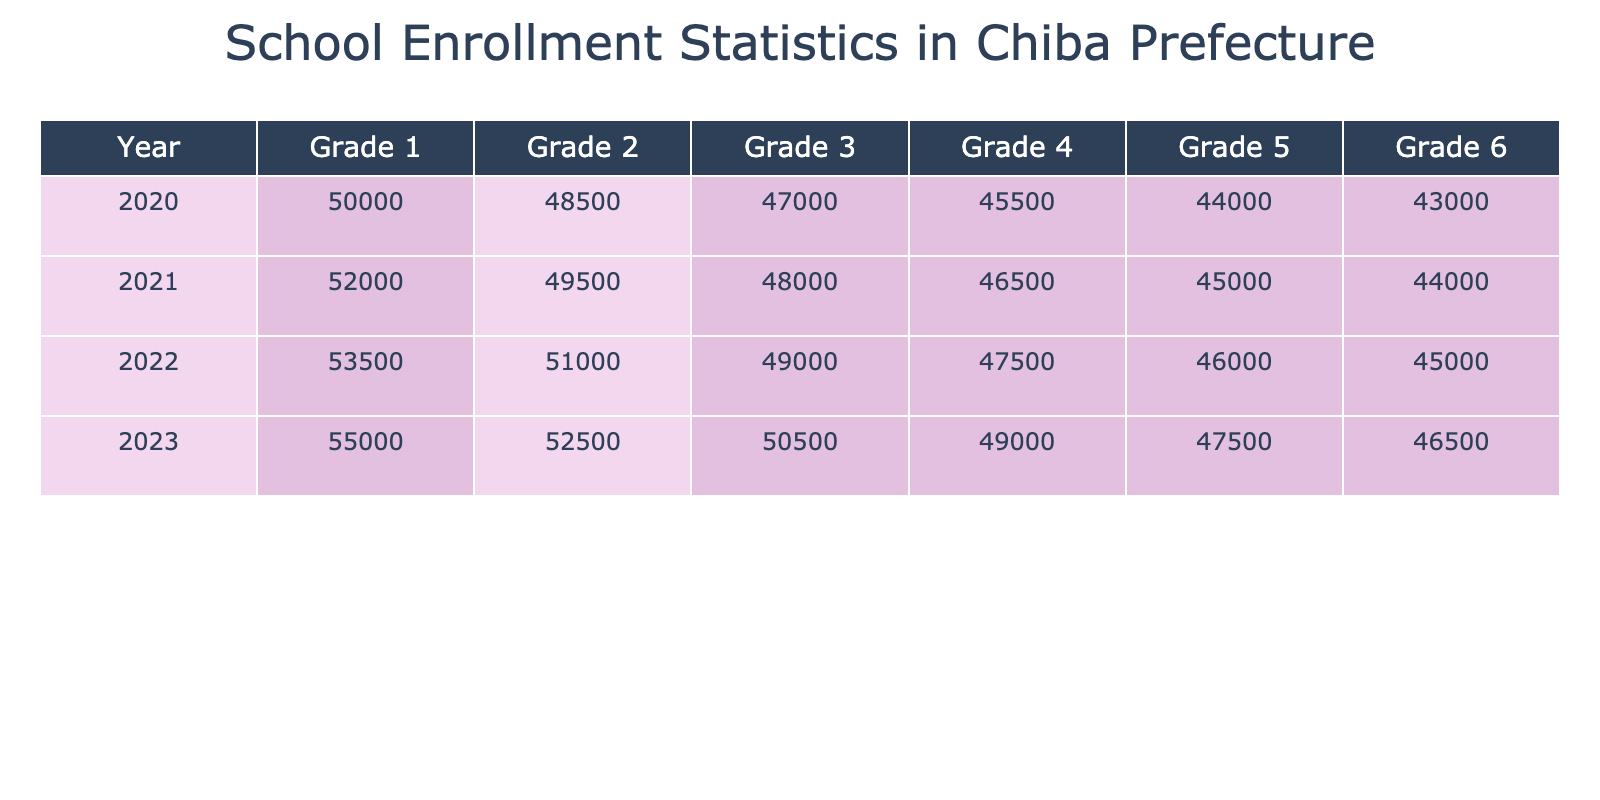What was the total enrollment for Grade 1 in 2022? The enrollment for Grade 1 in 2022 is listed in the table under that specific year and grade level. According to the data, the Total Enrollment for Grade 1 in 2022 is 53,500.
Answer: 53,500 How many students were enrolled in private schools in Grade 6 in 2021? The enrollment specifically for Grade 6 in the year 2021 needs to be looked up in the respective row. According to the data, the Private Schools Enrollment for Grade 6 in 2021 is 13,000.
Answer: 13,000 What is the difference in total enrollment between Grade 3 in 2020 and Grade 3 in 2023? To find this difference, we first look up the Total Enrollment for Grade 3 in both years from the table. For 2020, the total is 47,000 and for 2023, it is 50,500. The difference is calculated as 50,500 - 47,000 = 3,500.
Answer: 3,500 Is the total enrollment in Grade 5 in 2021 higher than in 2020? We need to find the Total Enrollment figures for Grade 5 in both years. In 2021, the Total Enrollment for Grade 5 is 45,000 and in 2020 it is 44,000. Comparing these two figures, 45,000 is indeed higher than 44,000. Therefore, the answer is Yes.
Answer: Yes What grade level had the highest total enrollment in 2023 and what was that enrollment? We need to check the Total Enrollment for all grade levels in 2023. In that year, Grade 1 has 55,000, Grade 2 has 52,500, Grade 3 has 50,500, Grade 4 has 49,000, Grade 5 has 47,500, and Grade 6 has 46,500. The highest is 55,000 for Grade 1.
Answer: Grade 1, 55,000 